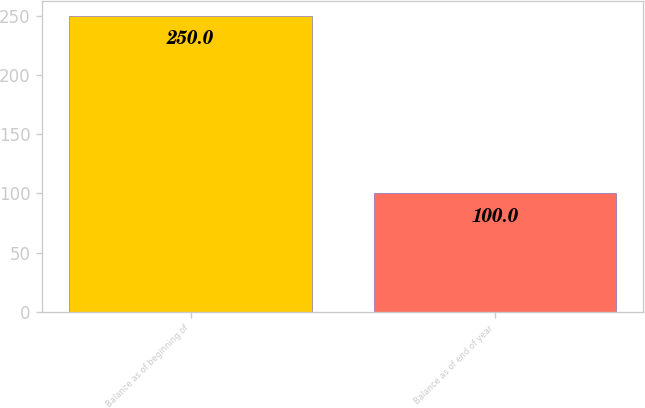Convert chart. <chart><loc_0><loc_0><loc_500><loc_500><bar_chart><fcel>Balance as of beginning of<fcel>Balance as of end of year<nl><fcel>250<fcel>100<nl></chart> 